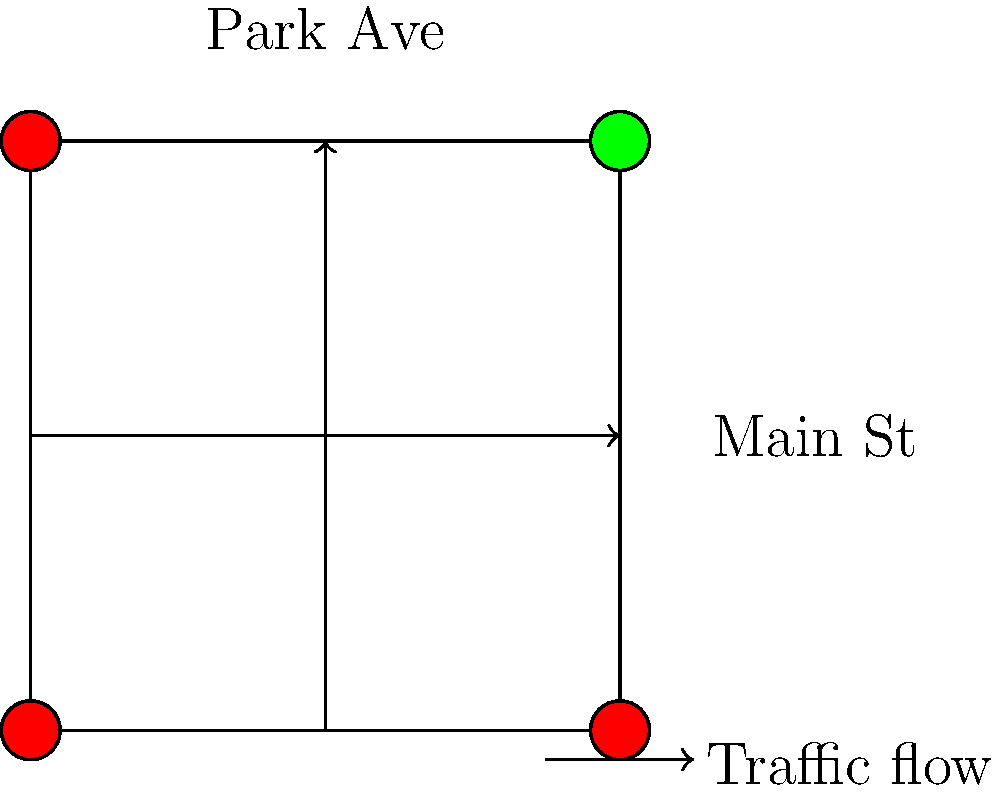You're optimizing the traffic flow at a busy intersection near your kids' school. The intersection has two lanes in each direction on both Main St and Park Ave. During peak hours, the traffic volume on Main St is 1200 vehicles per hour, while Park Ave has 800 vehicles per hour. What would be the optimal cycle length in seconds for the traffic signals to minimize overall delay, assuming a lost time of 4 seconds per phase? To optimize the traffic flow and minimize overall delay, we need to calculate the optimal cycle length using Webster's formula. Let's break it down step-by-step:

1. Webster's formula for optimal cycle length is:

   $$C_o = \frac{1.5L + 5}{1 - Y}$$

   Where:
   $C_o$ = Optimal cycle length (seconds)
   $L$ = Total lost time per cycle (seconds)
   $Y$ = Sum of critical phase flow ratios

2. Calculate the total lost time ($L$):
   - There are two phases (Main St and Park Ave)
   - Lost time per phase = 4 seconds
   - $L = 2 \times 4 = 8$ seconds

3. Calculate the critical flow ratio ($y$) for each phase:
   - Main St: $y_1 = \frac{1200}{1900} = 0.63$ (assuming saturation flow of 1900 veh/hr/lane)
   - Park Ave: $y_2 = \frac{800}{1900} = 0.42$

4. Calculate the sum of critical phase flow ratios ($Y$):
   $Y = y_1 + y_2 = 0.63 + 0.42 = 1.05$

5. Apply Webster's formula:
   $$C_o = \frac{1.5 \times 8 + 5}{1 - 1.05} = \frac{17}{-0.05} = -340$$

6. Since we got a negative value, which is not practical, we need to use a practical range for cycle lengths, typically between 60 and 120 seconds.

7. In this case, we'll choose the maximum practical cycle length of 120 seconds to accommodate the high traffic volume.
Answer: 120 seconds 